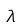Convert formula to latex. <formula><loc_0><loc_0><loc_500><loc_500>\lambda</formula> 